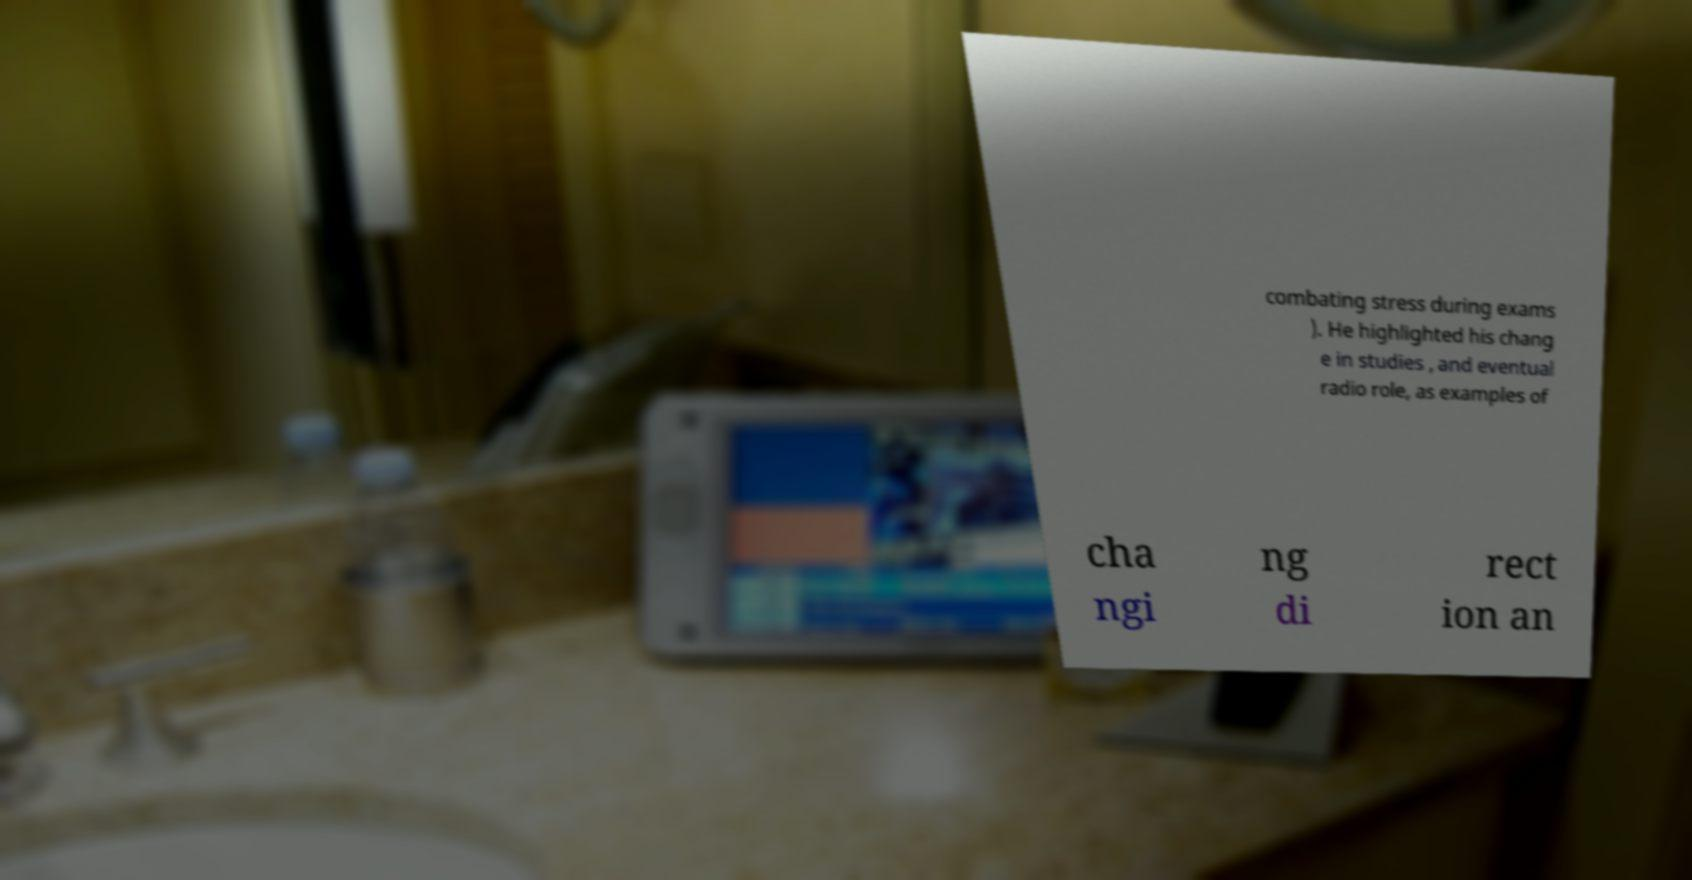There's text embedded in this image that I need extracted. Can you transcribe it verbatim? combating stress during exams ). He highlighted his chang e in studies , and eventual radio role, as examples of cha ngi ng di rect ion an 